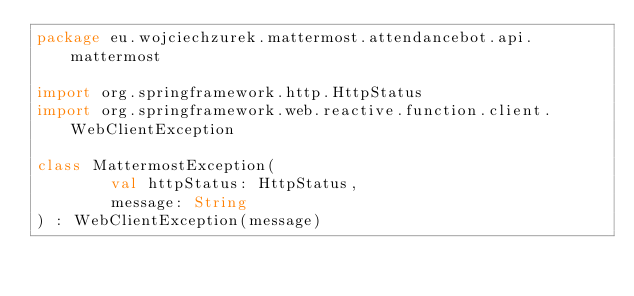<code> <loc_0><loc_0><loc_500><loc_500><_Kotlin_>package eu.wojciechzurek.mattermost.attendancebot.api.mattermost

import org.springframework.http.HttpStatus
import org.springframework.web.reactive.function.client.WebClientException

class MattermostException(
        val httpStatus: HttpStatus,
        message: String
) : WebClientException(message)</code> 